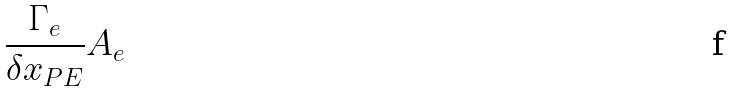<formula> <loc_0><loc_0><loc_500><loc_500>\frac { \Gamma _ { e } } { \delta x _ { P E } } A _ { e }</formula> 